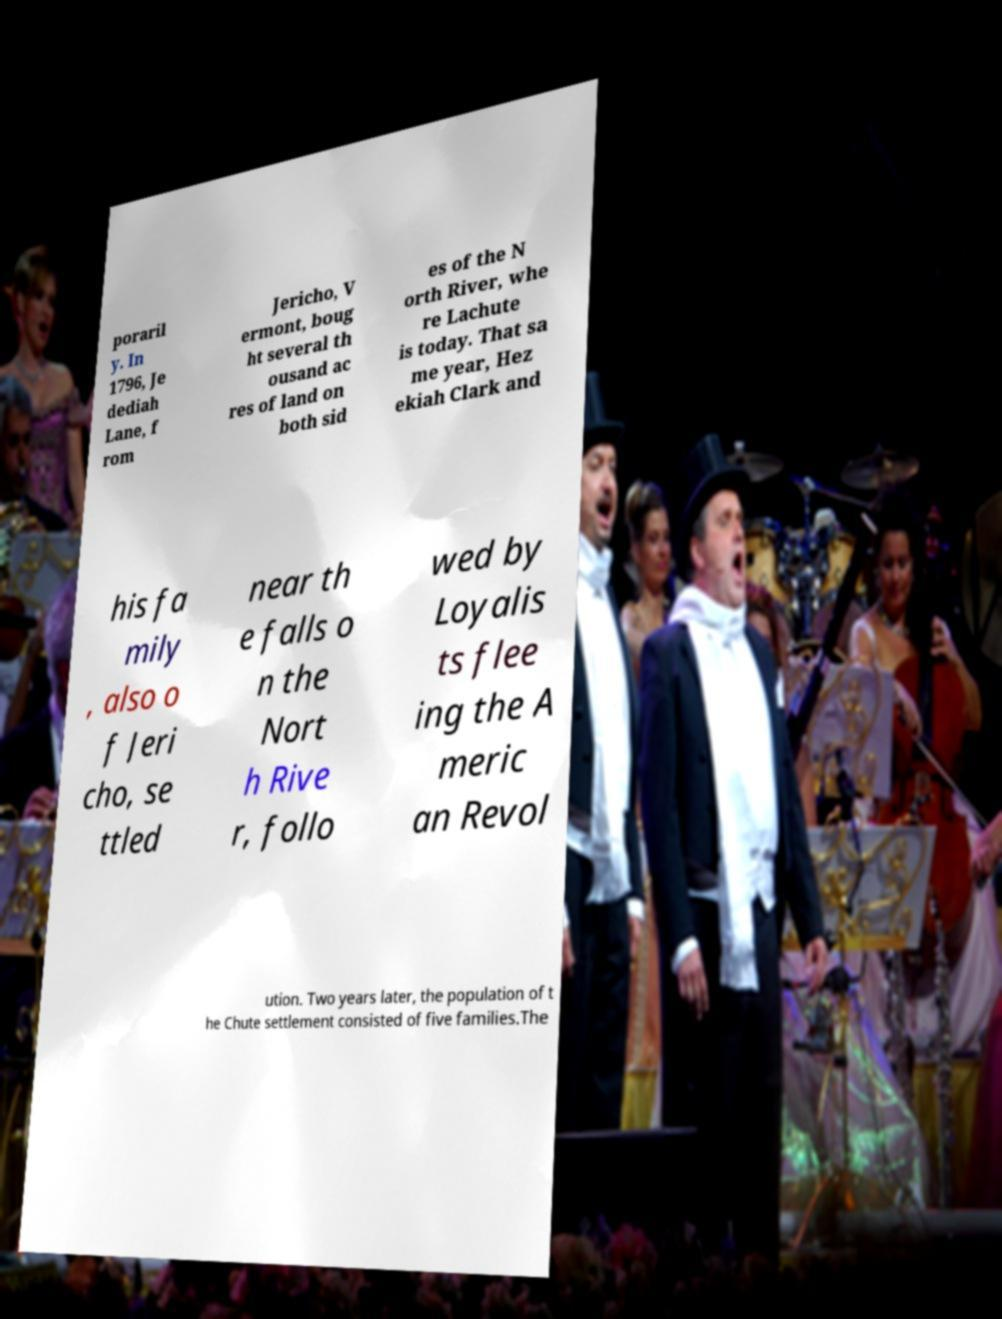Please read and relay the text visible in this image. What does it say? poraril y. In 1796, Je dediah Lane, f rom Jericho, V ermont, boug ht several th ousand ac res of land on both sid es of the N orth River, whe re Lachute is today. That sa me year, Hez ekiah Clark and his fa mily , also o f Jeri cho, se ttled near th e falls o n the Nort h Rive r, follo wed by Loyalis ts flee ing the A meric an Revol ution. Two years later, the population of t he Chute settlement consisted of five families.The 